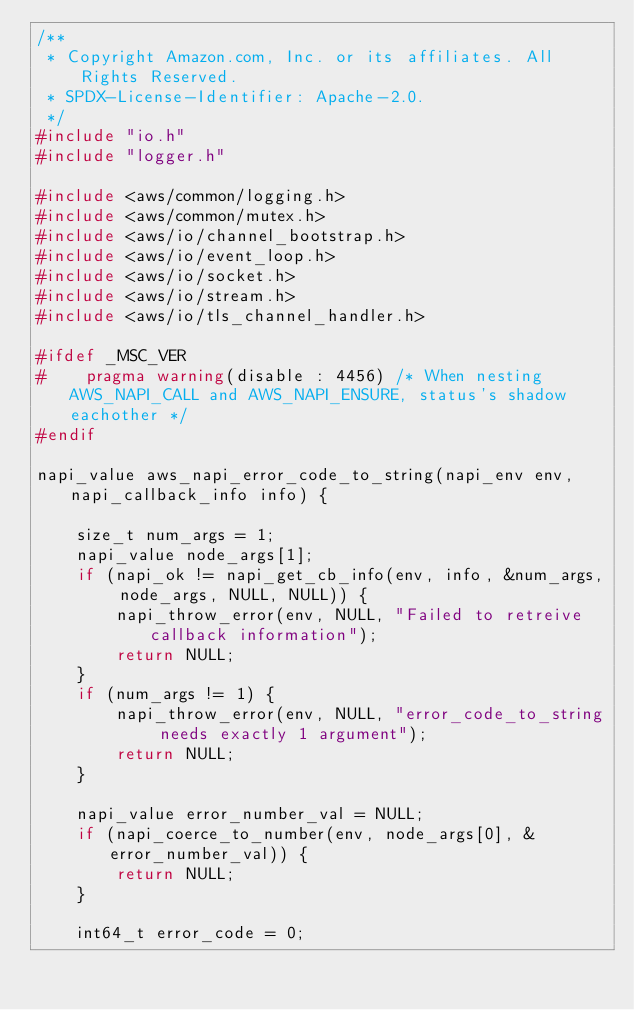<code> <loc_0><loc_0><loc_500><loc_500><_C_>/**
 * Copyright Amazon.com, Inc. or its affiliates. All Rights Reserved.
 * SPDX-License-Identifier: Apache-2.0.
 */
#include "io.h"
#include "logger.h"

#include <aws/common/logging.h>
#include <aws/common/mutex.h>
#include <aws/io/channel_bootstrap.h>
#include <aws/io/event_loop.h>
#include <aws/io/socket.h>
#include <aws/io/stream.h>
#include <aws/io/tls_channel_handler.h>

#ifdef _MSC_VER
#    pragma warning(disable : 4456) /* When nesting AWS_NAPI_CALL and AWS_NAPI_ENSURE, status's shadow eachother */
#endif

napi_value aws_napi_error_code_to_string(napi_env env, napi_callback_info info) {

    size_t num_args = 1;
    napi_value node_args[1];
    if (napi_ok != napi_get_cb_info(env, info, &num_args, node_args, NULL, NULL)) {
        napi_throw_error(env, NULL, "Failed to retreive callback information");
        return NULL;
    }
    if (num_args != 1) {
        napi_throw_error(env, NULL, "error_code_to_string needs exactly 1 argument");
        return NULL;
    }

    napi_value error_number_val = NULL;
    if (napi_coerce_to_number(env, node_args[0], &error_number_val)) {
        return NULL;
    }

    int64_t error_code = 0;</code> 